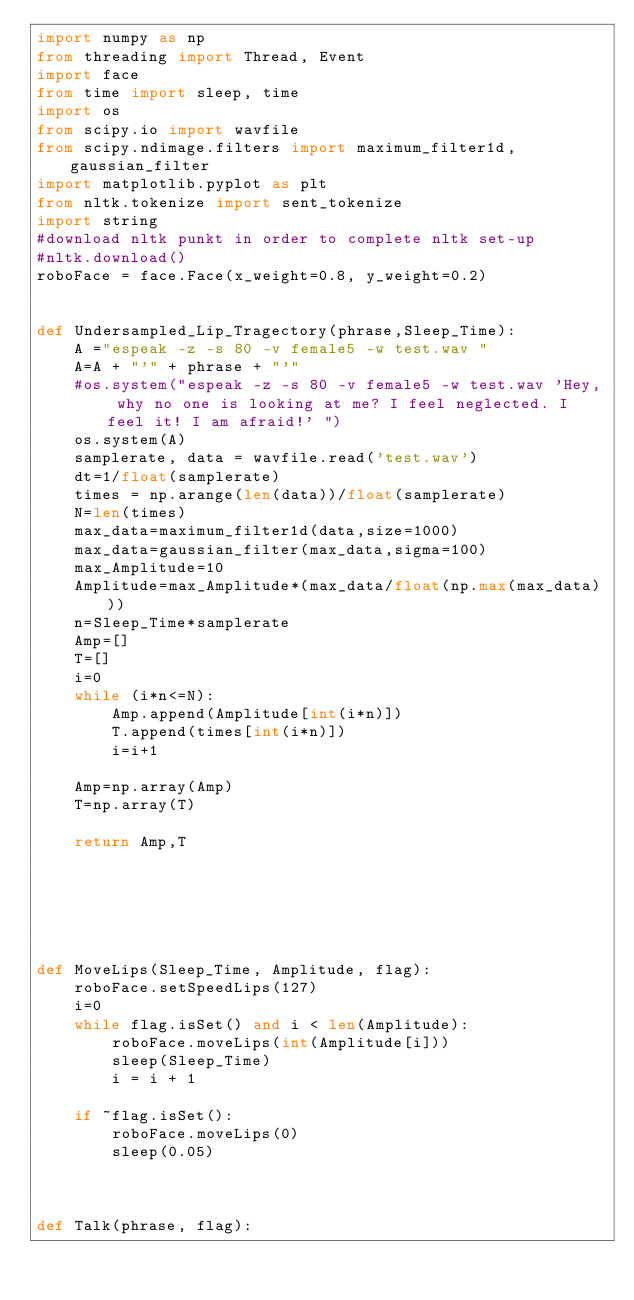<code> <loc_0><loc_0><loc_500><loc_500><_Python_>import numpy as np
from threading import Thread, Event
import face
from time import sleep, time
import os
from scipy.io import wavfile
from scipy.ndimage.filters import maximum_filter1d,gaussian_filter
import matplotlib.pyplot as plt
from nltk.tokenize import sent_tokenize
import string
#download nltk punkt in order to complete nltk set-up
#nltk.download()
roboFace = face.Face(x_weight=0.8, y_weight=0.2)


def Undersampled_Lip_Tragectory(phrase,Sleep_Time):
    A ="espeak -z -s 80 -v female5 -w test.wav "
    A=A + "'" + phrase + "'"
    #os.system("espeak -z -s 80 -v female5 -w test.wav 'Hey, why no one is looking at me? I feel neglected. I feel it! I am afraid!' ")
    os.system(A)
    samplerate, data = wavfile.read('test.wav')
    dt=1/float(samplerate)
    times = np.arange(len(data))/float(samplerate)
    N=len(times)
    max_data=maximum_filter1d(data,size=1000)
    max_data=gaussian_filter(max_data,sigma=100)
    max_Amplitude=10
    Amplitude=max_Amplitude*(max_data/float(np.max(max_data)))
    n=Sleep_Time*samplerate
    Amp=[]
    T=[]
    i=0
    while (i*n<=N):
        Amp.append(Amplitude[int(i*n)])
        T.append(times[int(i*n)])
        i=i+1

    Amp=np.array(Amp)
    T=np.array(T)
   
    return Amp,T






def MoveLips(Sleep_Time, Amplitude, flag):
    roboFace.setSpeedLips(127)
    i=0
    while flag.isSet() and i < len(Amplitude):
        roboFace.moveLips(int(Amplitude[i]))
        sleep(Sleep_Time)
        i = i + 1
    
    if ~flag.isSet():
        roboFace.moveLips(0)
        sleep(0.05)
    


def Talk(phrase, flag):</code> 